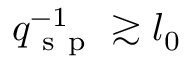<formula> <loc_0><loc_0><loc_500><loc_500>q _ { s p } ^ { - 1 } \gtrsim l _ { 0 }</formula> 